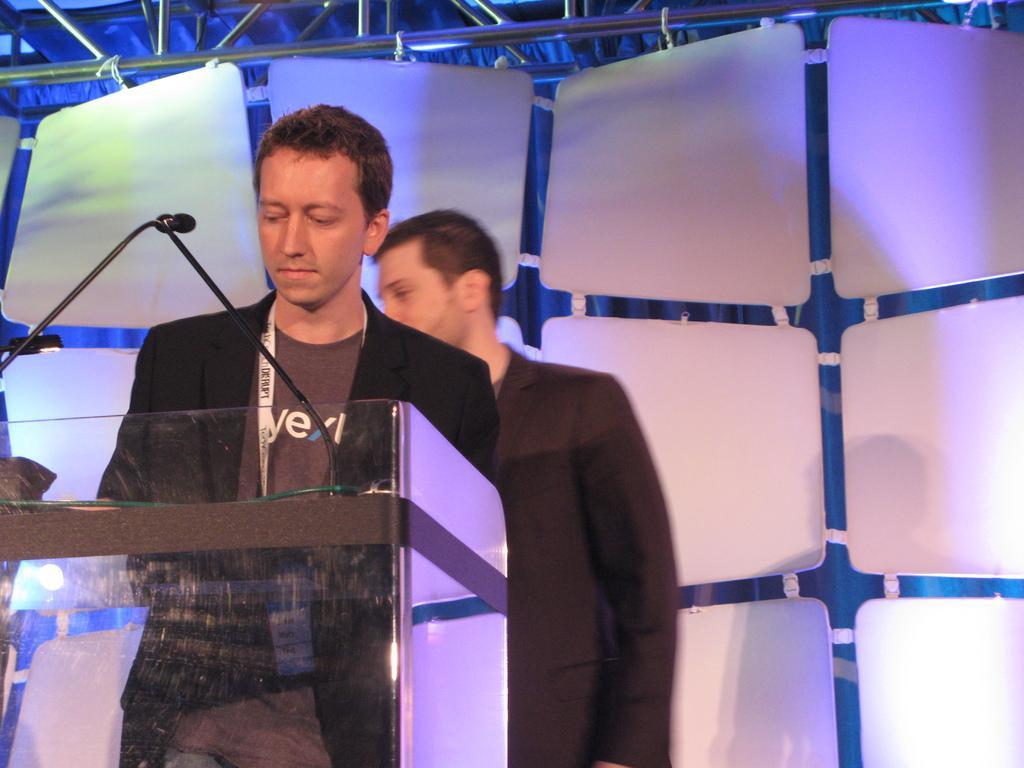Can you describe this image briefly? There is a person standing and wearing a tag. In front of him there is a stand with mics. In the back there is another person. Also there are rods and curtains in the background. 